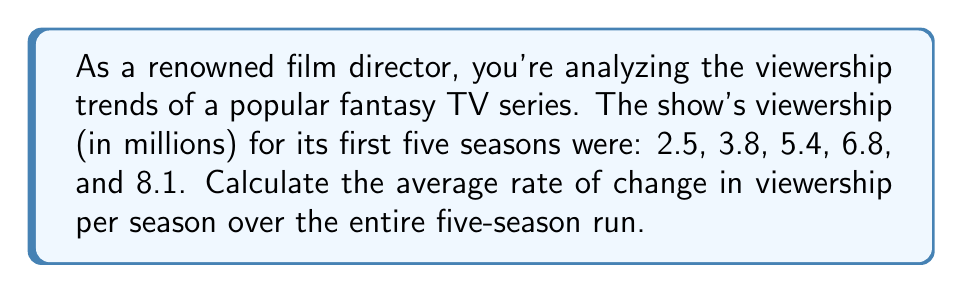Could you help me with this problem? Let's approach this step-by-step:

1) The rate of change is calculated using the formula:
   
   $$\text{Rate of Change} = \frac{\text{Change in y}}{\text{Change in x}}$$

2) In this case:
   - y represents viewership (in millions)
   - x represents seasons
   
3) We need to find the total change in viewership from season 1 to season 5:
   
   $$\text{Change in viewership} = 8.1 - 2.5 = 5.6 \text{ million}$$

4) The change in seasons is:
   
   $$\text{Change in seasons} = 5 - 1 = 4 \text{ seasons}$$

5) Now we can calculate the average rate of change:

   $$\text{Average Rate of Change} = \frac{5.6}{4} = 1.4$$

6) Therefore, the average rate of change in viewership is 1.4 million viewers per season.
Answer: 1.4 million viewers/season 